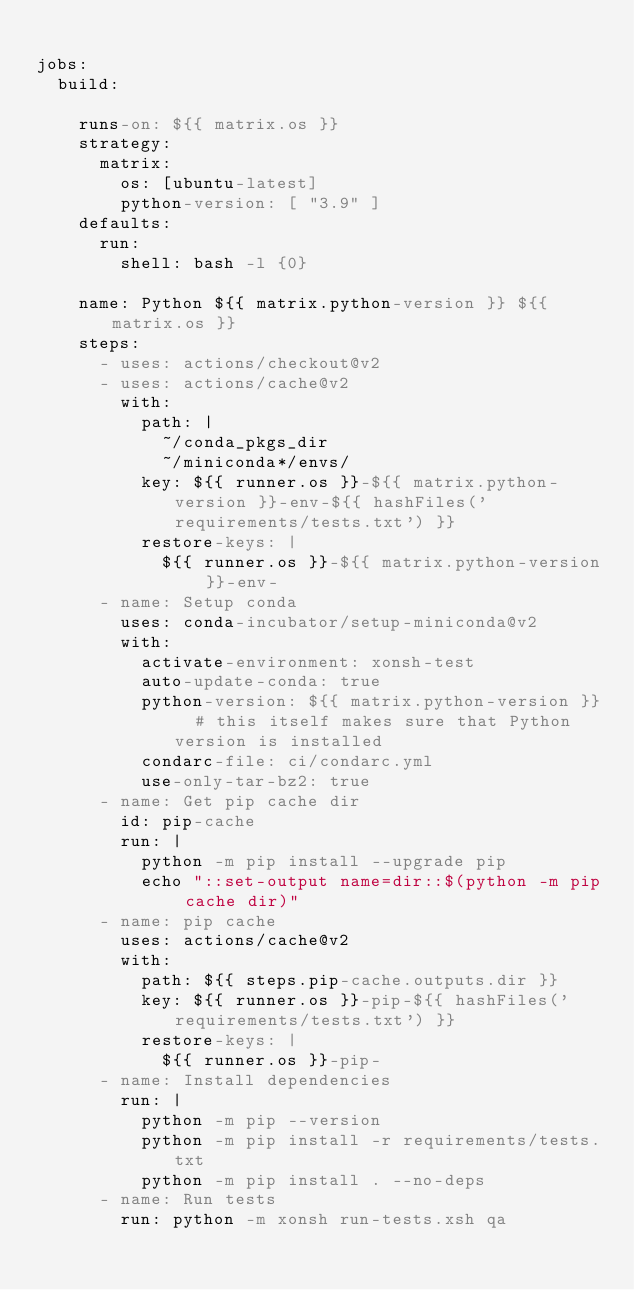<code> <loc_0><loc_0><loc_500><loc_500><_YAML_>
jobs:
  build:

    runs-on: ${{ matrix.os }}
    strategy:
      matrix:
        os: [ubuntu-latest]
        python-version: [ "3.9" ]
    defaults:
      run:
        shell: bash -l {0}

    name: Python ${{ matrix.python-version }} ${{ matrix.os }}
    steps:
      - uses: actions/checkout@v2
      - uses: actions/cache@v2
        with:
          path: |
            ~/conda_pkgs_dir
            ~/miniconda*/envs/
          key: ${{ runner.os }}-${{ matrix.python-version }}-env-${{ hashFiles('requirements/tests.txt') }}
          restore-keys: |
            ${{ runner.os }}-${{ matrix.python-version }}-env-
      - name: Setup conda
        uses: conda-incubator/setup-miniconda@v2
        with:
          activate-environment: xonsh-test
          auto-update-conda: true
          python-version: ${{ matrix.python-version }}  # this itself makes sure that Python version is installed
          condarc-file: ci/condarc.yml
          use-only-tar-bz2: true
      - name: Get pip cache dir
        id: pip-cache
        run: |
          python -m pip install --upgrade pip
          echo "::set-output name=dir::$(python -m pip cache dir)"
      - name: pip cache
        uses: actions/cache@v2
        with:
          path: ${{ steps.pip-cache.outputs.dir }}
          key: ${{ runner.os }}-pip-${{ hashFiles('requirements/tests.txt') }}
          restore-keys: |
            ${{ runner.os }}-pip-
      - name: Install dependencies
        run: |
          python -m pip --version
          python -m pip install -r requirements/tests.txt
          python -m pip install . --no-deps
      - name: Run tests
        run: python -m xonsh run-tests.xsh qa
</code> 